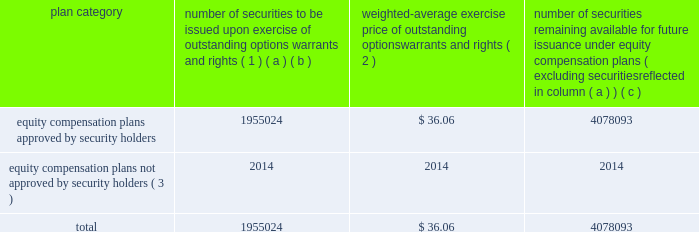Equity compensation plan information the table presents the equity securities available for issuance under our equity compensation plans as of december 31 , 2014 .
Equity compensation plan information plan category number of securities to be issued upon exercise of outstanding options , warrants and rights ( 1 ) weighted-average exercise price of outstanding options , warrants and rights ( 2 ) number of securities remaining available for future issuance under equity compensation plans ( excluding securities reflected in column ( a ) ) ( a ) ( b ) ( c ) equity compensation plans approved by security holders 1955024 $ 36.06 4078093 equity compensation plans not approved by security holders ( 3 ) 2014 2014 2014 .
( 1 ) includes grants made under the huntington ingalls industries , inc .
2012 long-term incentive stock plan ( the "2012 plan" ) , which was approved by our stockholders on may 2 , 2012 , and the huntington ingalls industries , inc .
2011 long-term incentive stock plan ( the "2011 plan" ) , which was approved by the sole stockholder of hii prior to its spin-off from northrop grumman corporation .
Of these shares , 644321 were subject to stock options , 539742 were subject to outstanding restricted performance stock rights , and 63022 were stock rights granted under the 2011 plan .
In addition , this number includes 33571 stock rights , 11046 restricted stock rights and 663322 restricted performance stock rights granted under the 2012 plan , assuming target performance achievement .
( 2 ) this is the weighted average exercise price of the 644321 outstanding stock options only .
( 3 ) there are no awards made under plans not approved by security holders .
Item 13 .
Certain relationships and related transactions , and director independence information as to certain relationships and related transactions and director independence will be incorporated herein by reference to the proxy statement for our 2015 annual meeting of stockholders to be filed within 120 days after the end of the company 2019s fiscal year .
Item 14 .
Principal accountant fees and services information as to principal accountant fees and services will be incorporated herein by reference to the proxy statement for our 2015 annual meeting of stockholders to be filed within 120 days after the end of the company 2019s fiscal year .
This proof is printed at 96% ( 96 % ) of original size this line represents final trim and will not print .
At the weighted average price given what is the value of the number of securities to be issued? 
Rationale: the value is the product of the number of shares and the price
Computations: (1955024 * 36.06)
Answer: 70498165.44. 